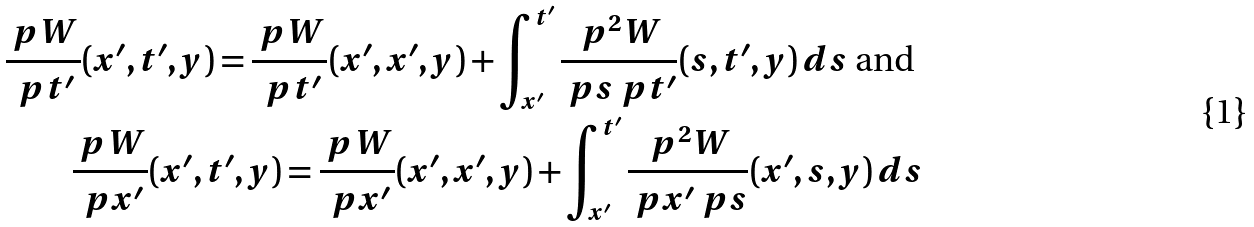<formula> <loc_0><loc_0><loc_500><loc_500>\frac { \ p W } { \ p t ^ { \prime } } ( x ^ { \prime } , t ^ { \prime } , y ) = \frac { \ p W } { \ p t ^ { \prime } } ( x ^ { \prime } , x ^ { \prime } , y ) + \int _ { x ^ { \prime } } ^ { t ^ { \prime } } \frac { \ p ^ { 2 } W } { \ p s \ p t ^ { \prime } } ( s , t ^ { \prime } , y ) \, d s \text { and } \\ \frac { \ p W } { \ p x ^ { \prime } } ( x ^ { \prime } , t ^ { \prime } , y ) = \frac { \ p W } { \ p x ^ { \prime } } ( x ^ { \prime } , x ^ { \prime } , y ) + \int _ { x ^ { \prime } } ^ { t ^ { \prime } } \frac { \ p ^ { 2 } W } { \ p x ^ { \prime } \ p s } ( x ^ { \prime } , s , y ) \, d s</formula> 